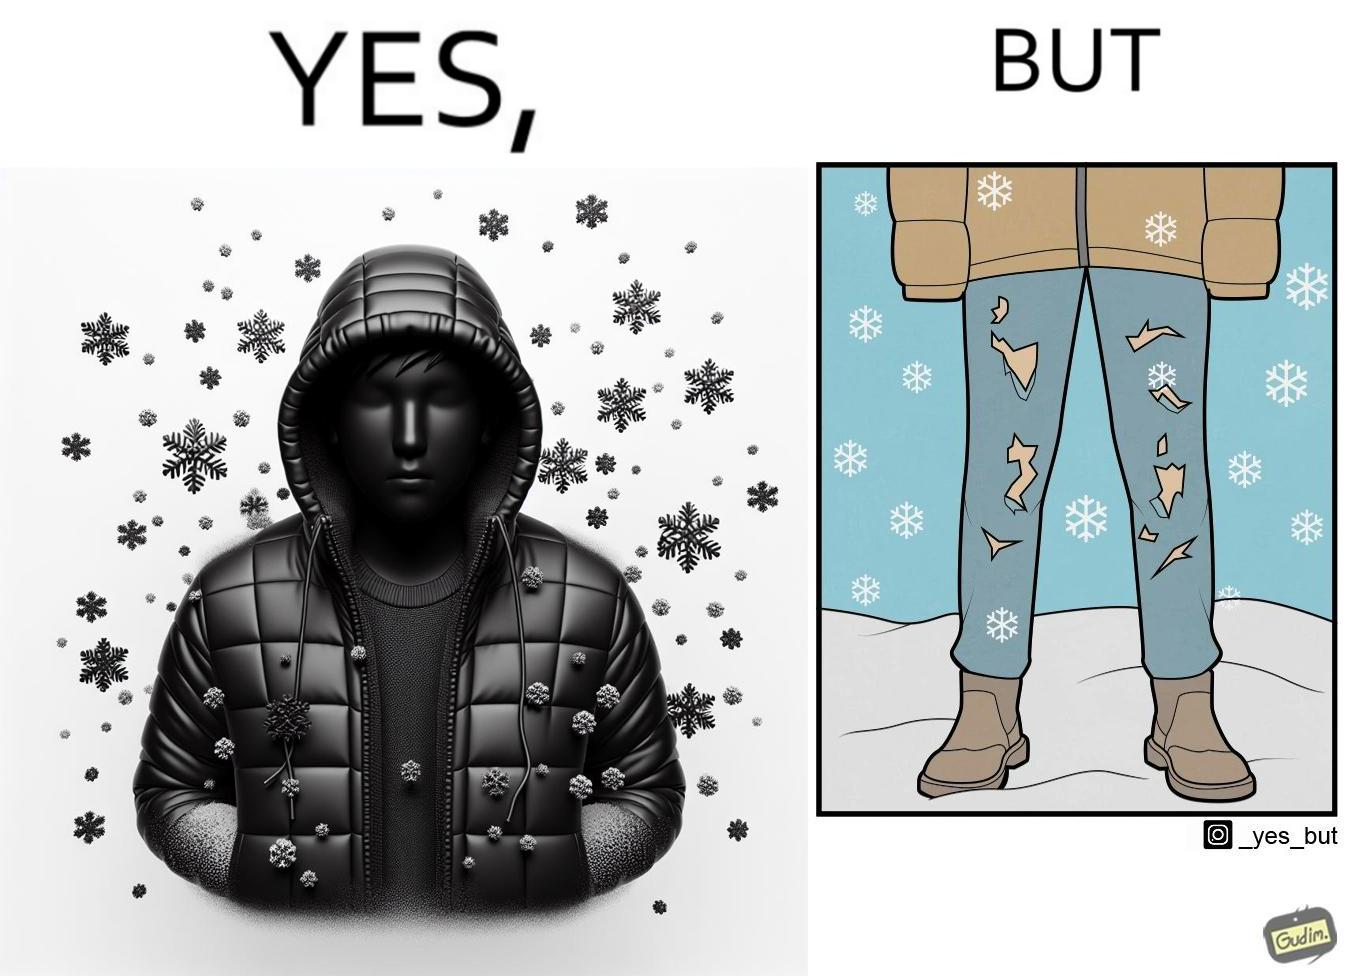Would you classify this image as satirical? Yes, this image is satirical. 